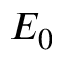Convert formula to latex. <formula><loc_0><loc_0><loc_500><loc_500>E _ { 0 }</formula> 